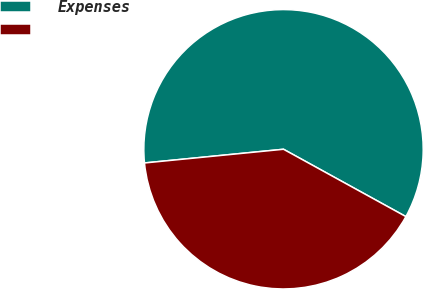Convert chart. <chart><loc_0><loc_0><loc_500><loc_500><pie_chart><fcel>Expenses<fcel>Unnamed: 1<nl><fcel>59.57%<fcel>40.43%<nl></chart> 